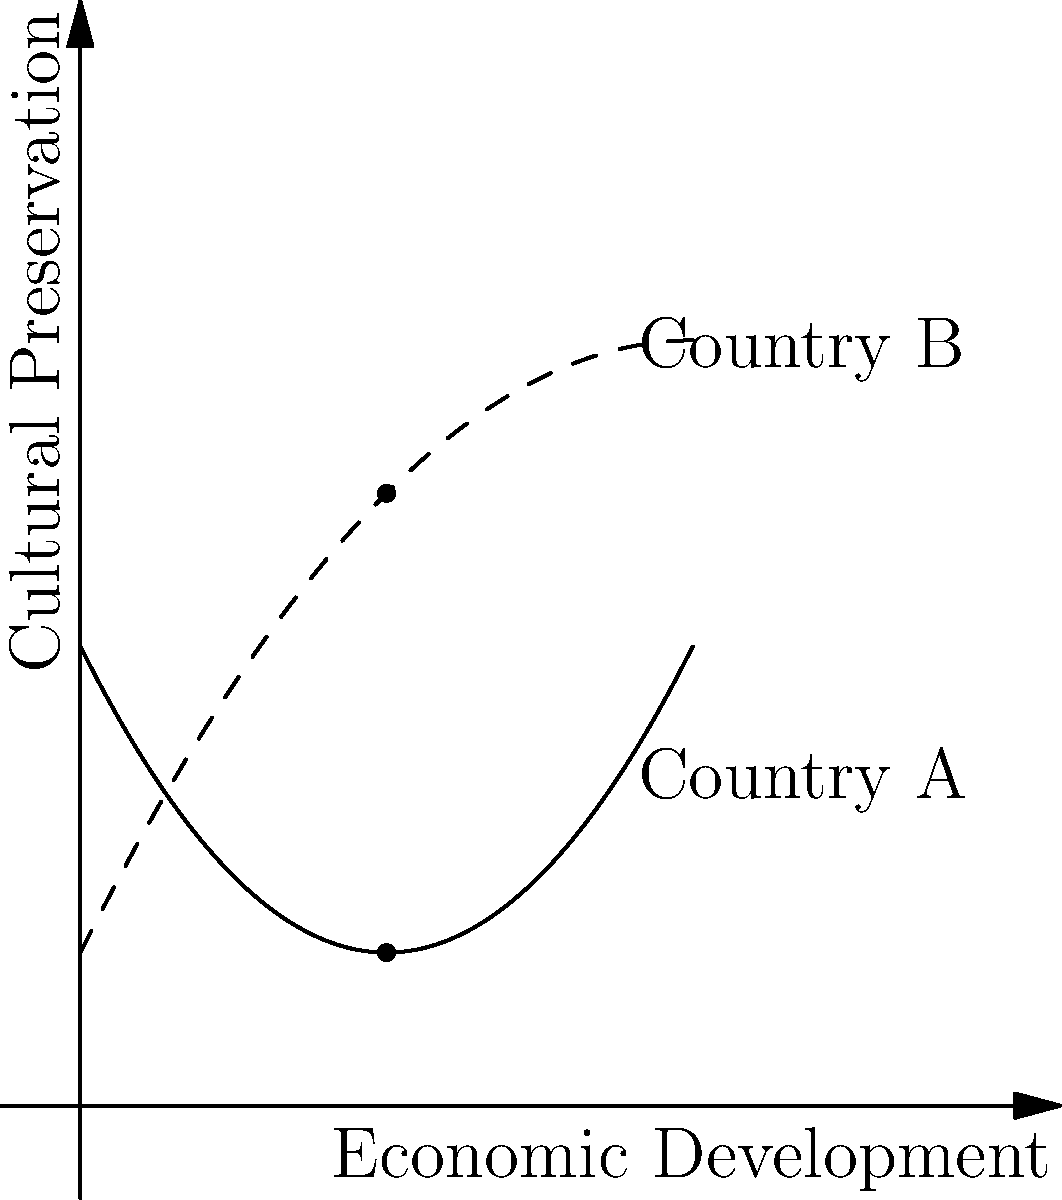The graph shows the relationship between economic development and cultural preservation for two East Asian countries, A and B. Based on the polynomial curves, at what level of economic development do both countries have the same level of cultural preservation? What does this intersection point suggest about the balance between development and cultural practices in these nations? To solve this problem, we need to follow these steps:

1. Identify the curves: 
   - Country A is represented by the solid curve (quadratic function, opening upwards)
   - Country B is represented by the dashed curve (quadratic function, opening downwards)

2. Find the intersection point:
   - The intersection occurs where the two curves meet
   - Visually, this appears to be at x ≈ 2 on the economic development axis

3. Interpret the intersection:
   - At this point, both countries have the same level of cultural preservation despite different economic development trajectories
   - Before this point, Country B has higher cultural preservation
   - After this point, Country A has higher cultural preservation

4. Analyze the implications:
   - The intersection suggests a critical point in development where cultural preservation strategies may shift
   - It indicates that the relationship between economic development and cultural preservation is not linear and varies between countries
   - The divergence after the intersection point implies different national approaches to balancing development and cultural preservation

5. Consider the broader context:
   - This model suggests that initial stages of development might challenge cultural preservation (Country A's curve)
   - However, some nations might find ways to preserve culture even with rapid early development (Country B's curve)
   - The long-term trends imply that highly developed countries may face different challenges in cultural preservation

The intersection point represents a pivotal moment where both countries have achieved the same balance between economic development and cultural preservation, despite following different paths. This suggests that there's no single universal relationship between development and cultural practices, but rather country-specific approaches that lead to different outcomes over time.
Answer: The countries have the same cultural preservation level at x ≈ 2 (economic development), indicating a critical point where development strategies and cultural preservation efforts may diverge between nations. 